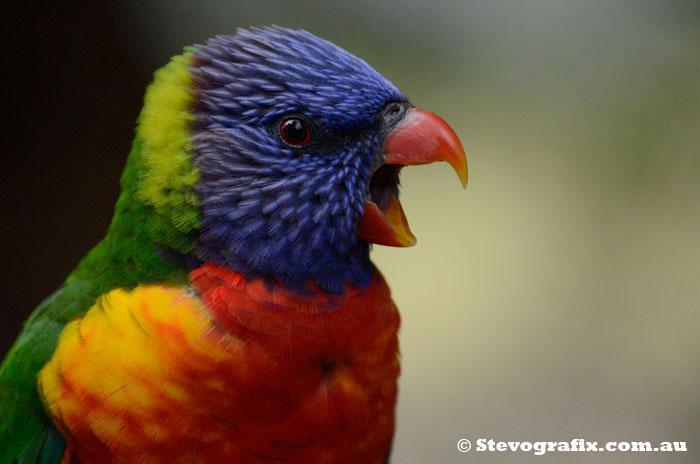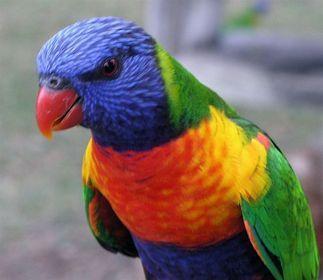The first image is the image on the left, the second image is the image on the right. Given the left and right images, does the statement "There are exactly two birds in the image on the left." hold true? Answer yes or no. No. 